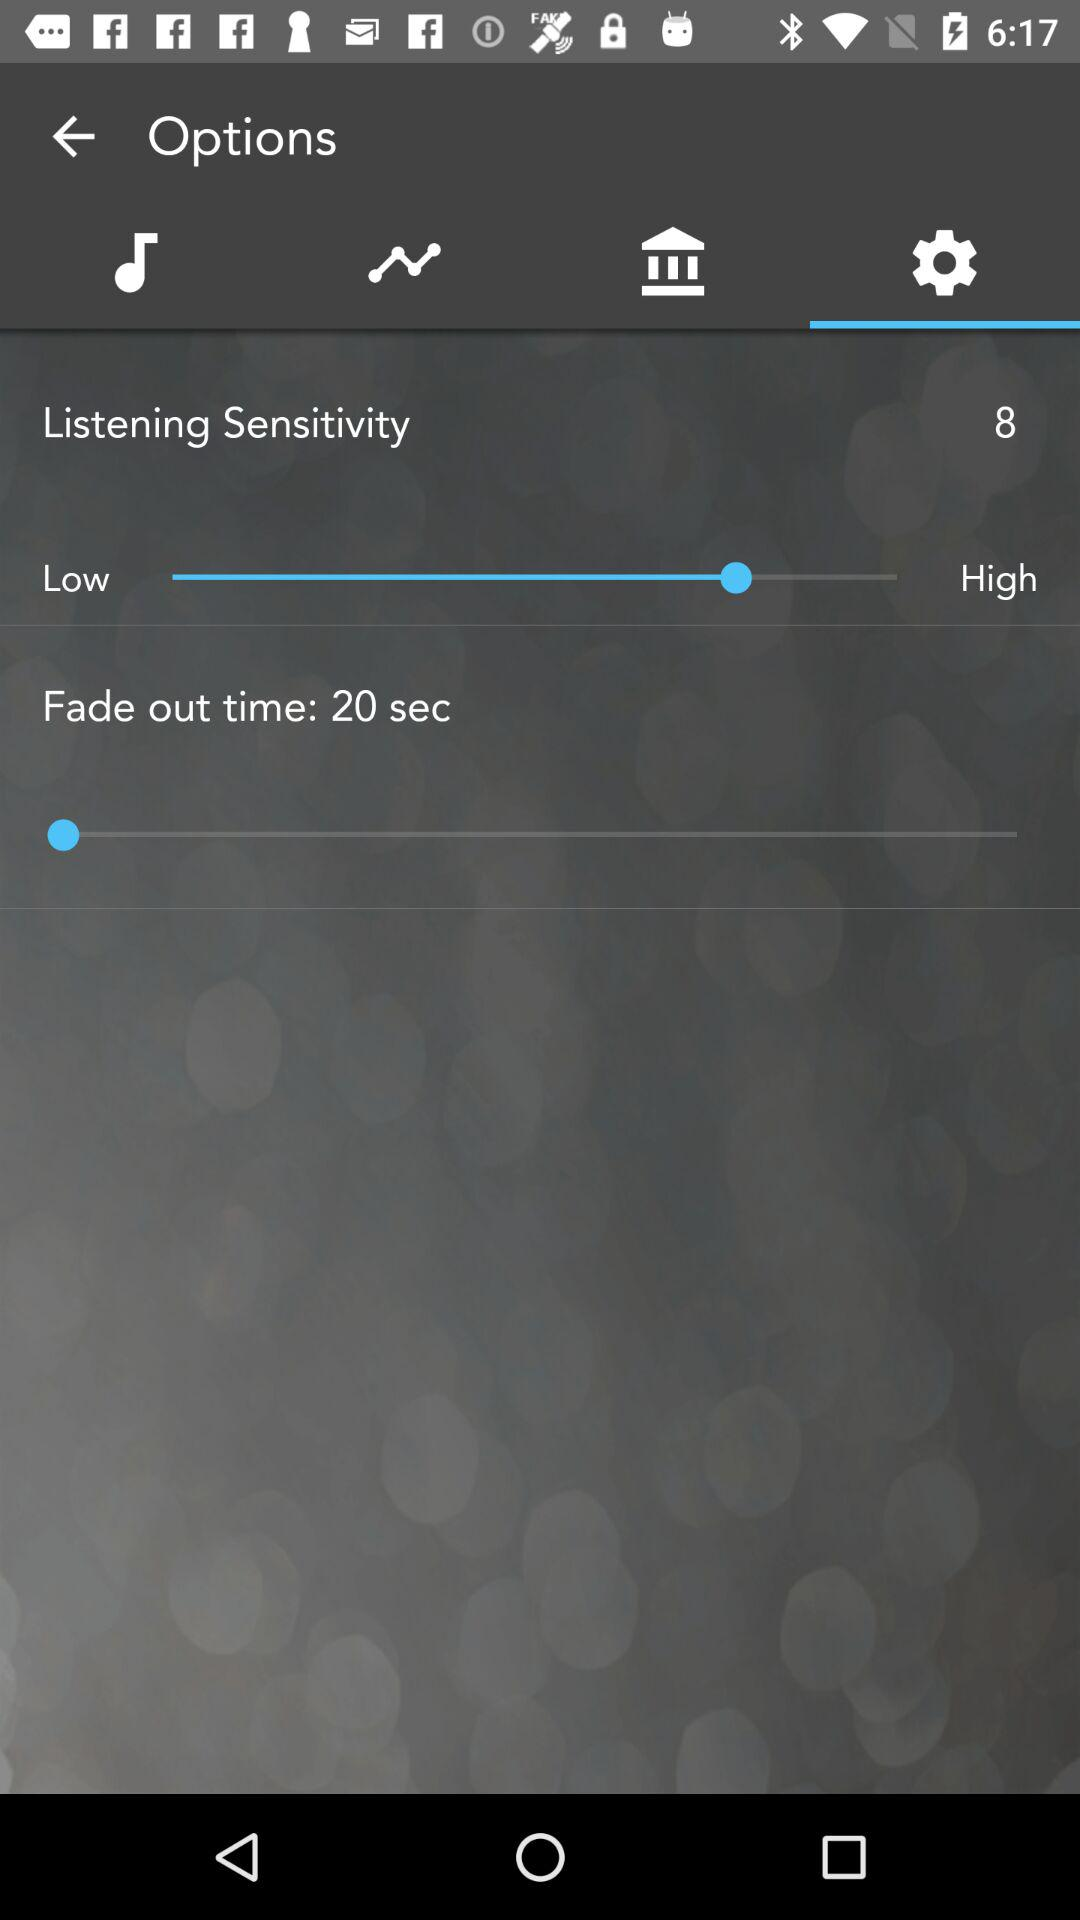What is the listening sensitivity level? The listening sensitivity level is 8. 